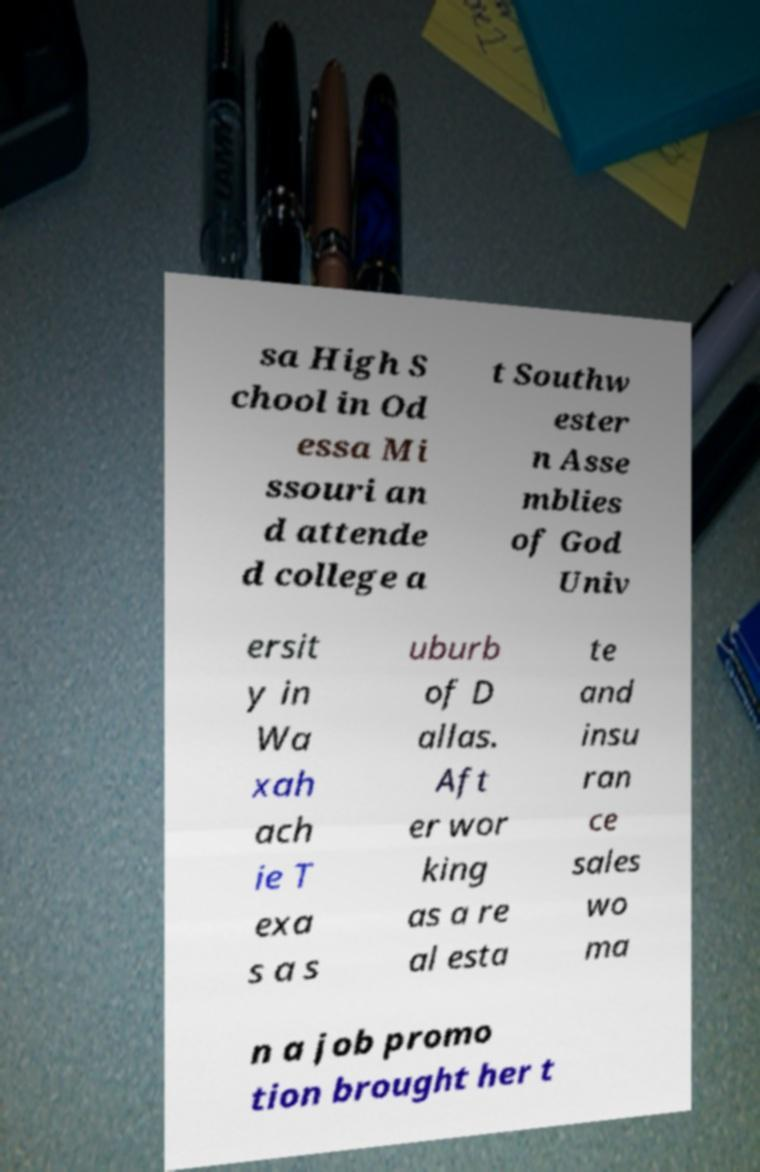I need the written content from this picture converted into text. Can you do that? sa High S chool in Od essa Mi ssouri an d attende d college a t Southw ester n Asse mblies of God Univ ersit y in Wa xah ach ie T exa s a s uburb of D allas. Aft er wor king as a re al esta te and insu ran ce sales wo ma n a job promo tion brought her t 